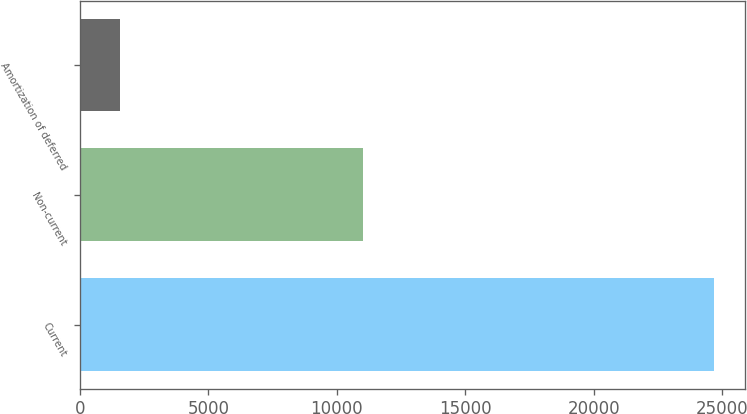Convert chart to OTSL. <chart><loc_0><loc_0><loc_500><loc_500><bar_chart><fcel>Current<fcel>Non-current<fcel>Amortization of deferred<nl><fcel>24653<fcel>11024<fcel>1561<nl></chart> 